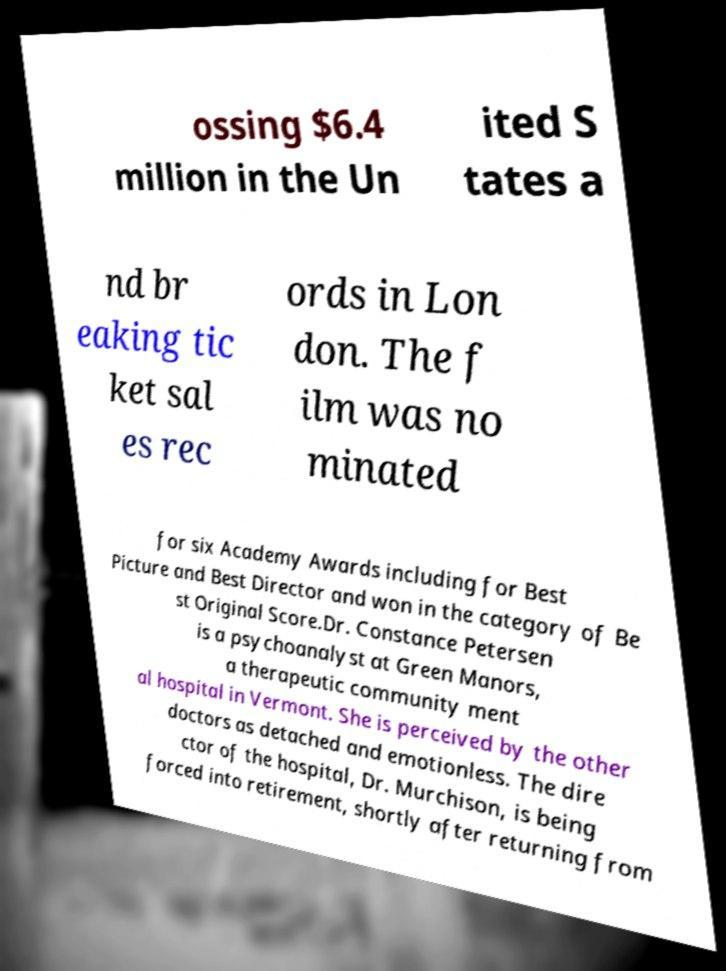Can you read and provide the text displayed in the image?This photo seems to have some interesting text. Can you extract and type it out for me? ossing $6.4 million in the Un ited S tates a nd br eaking tic ket sal es rec ords in Lon don. The f ilm was no minated for six Academy Awards including for Best Picture and Best Director and won in the category of Be st Original Score.Dr. Constance Petersen is a psychoanalyst at Green Manors, a therapeutic community ment al hospital in Vermont. She is perceived by the other doctors as detached and emotionless. The dire ctor of the hospital, Dr. Murchison, is being forced into retirement, shortly after returning from 